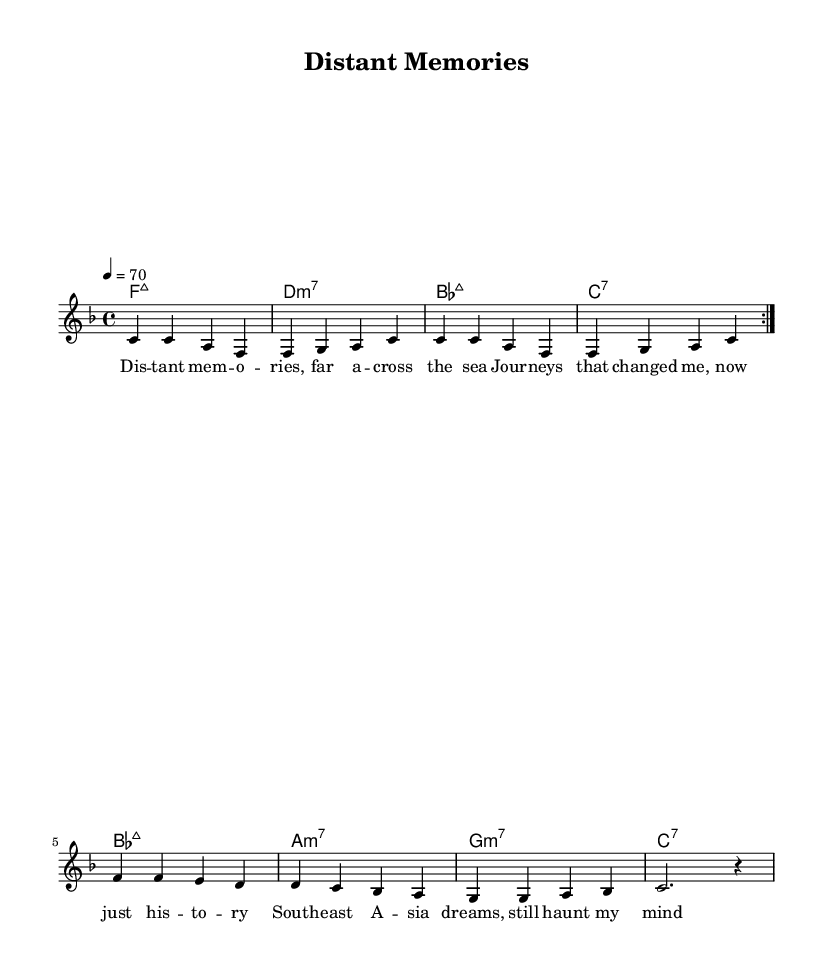What is the key signature of this music? The key signature indicates there is a single flat, which represents B flat. This is typical of F major, which has one flat in the key signature.
Answer: F major What is the time signature? The time signature appears at the beginning of the score and indicates 4 beats per measure, represented as 4/4.
Answer: 4/4 What is the tempo marking given in this music? The tempo marking is indicated by the number following "tempo" which is set to 70 beats per minute.
Answer: 70 How many times is the verse repeated? The music utilizes the repeat volta symbol, indicating the verse section is repeated twice.
Answer: 2 What is the last chord in the chord progression? The last chord of the progression is inferred from the sequence, where C7 is shown as the final chord. Thus, it's the last chord played before completing the chord sequence.
Answer: C7 What musical genre does this piece belong to? The lyrics and musical elements, such as the chord structures and melodic lines, evoke the smooth, soulful characteristics typical of Rhythm and Blues (R&B).
Answer: Rhythm and Blues What type of seventh chord is used in the second measure? The second measure displays a D minor 7 chord as denoted by the chord name; this is specifically a minor chord paired with a seventh.
Answer: D minor 7 